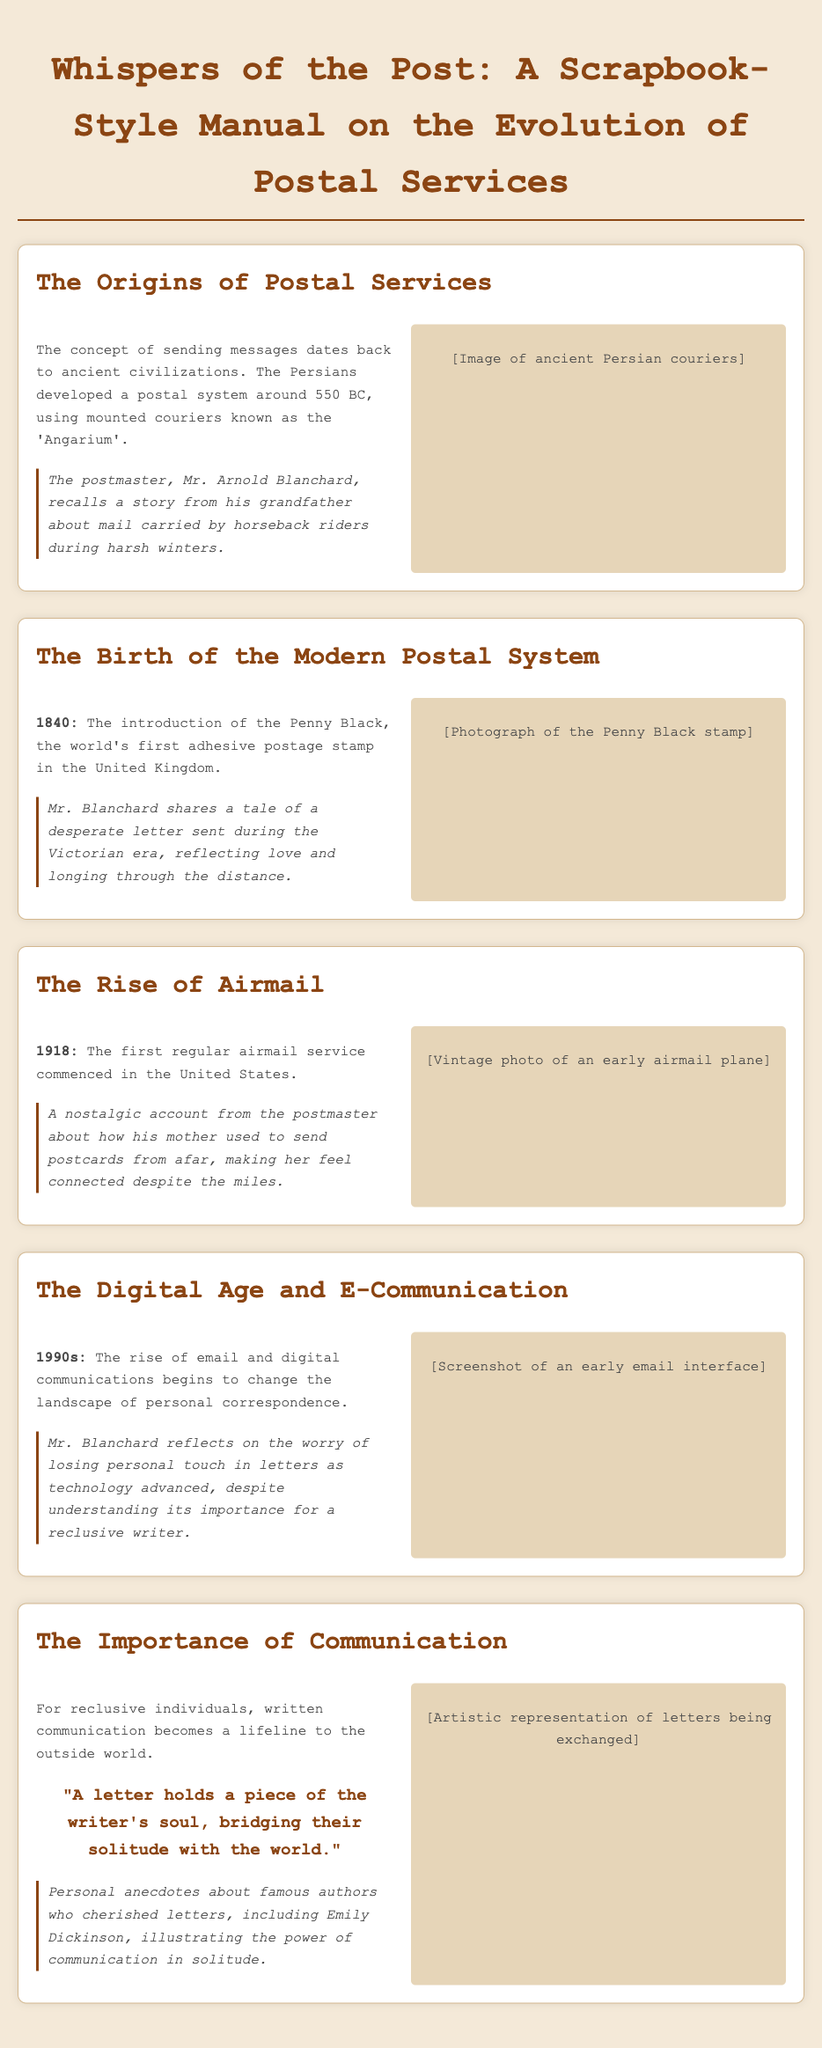What year was the Penny Black introduced? The Penny Black was introduced in the year 1840.
Answer: 1840 Who developed the postal system around 550 BC? The Persians developed the postal system around 550 BC.
Answer: Persians What is the significance of a letter according to the manual? A letter is described as holding a piece of the writer's soul, bridging solitude with the world.
Answer: A piece of the writer's soul In which year did the first regular airmail service commence in the United States? The first regular airmail service commenced in the United States in 1918.
Answer: 1918 What does Mr. Blanchard reflect on regarding technology's impact on communication? He reflects on the worry of losing personal touch in letters as technology advanced.
Answer: Losing personal touch What story does Mr. Blanchard share regarding his grandfather? He shares a story about mail carried by horseback riders during harsh winters.
Answer: Mail carried by horseback riders What is the main theme emphasized in the manual regarding reclusive individuals? The main theme is that written communication becomes a lifeline to the outside world.
Answer: Lifeline to the outside world What decade marks the rise of email and digital communications? The document indicates that the rise of email and digital communications began in the 1990s.
Answer: 1990s 